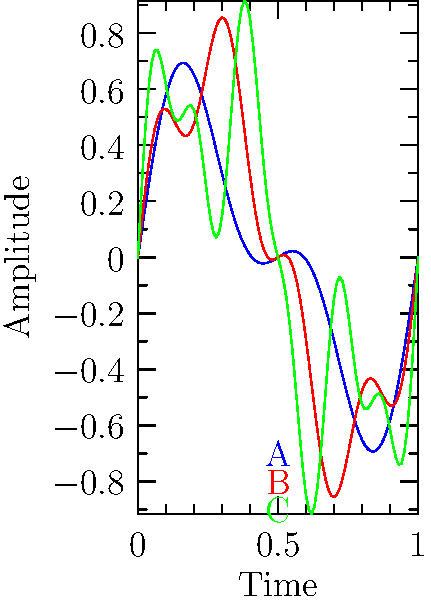As a rock music enthusiast and photographer, you're analyzing waveform patterns of different rock subgenres. The graph shows three distinct waveforms (A, B, and C) representing various rock styles. Which waveform is most likely associated with heavy metal, known for its complex harmonic structure and intense distortion? To answer this question, we need to analyze the characteristics of each waveform and relate them to the properties of heavy metal music:

1. Waveform A (blue):
   - Simple sine wave with a single dominant frequency
   - Smooth and relatively symmetrical
   - Lacks complexity typical of heavy metal

2. Waveform B (red):
   - More complex than A, with two visible frequency components
   - Still relatively smooth, lacking the intense distortion of heavy metal

3. Waveform C (green):
   - Most complex of the three waveforms
   - Contains multiple frequency components, visible as smaller oscillations
   - Irregular shape suggests presence of harmonics and distortion

Heavy metal is characterized by:
   - Complex harmonic structure due to distorted guitars
   - Intense distortion creating rich overtones
   - Dense sound with multiple frequency components

Comparing these characteristics:
   - Waveform C best represents heavy metal due to its complexity and irregular shape
   - The multiple frequency components in C align with the rich harmonic content of heavy metal
   - The irregular shape of C suggests the presence of distortion, a key element in heavy metal

Therefore, waveform C is most likely associated with heavy metal.
Answer: Waveform C 